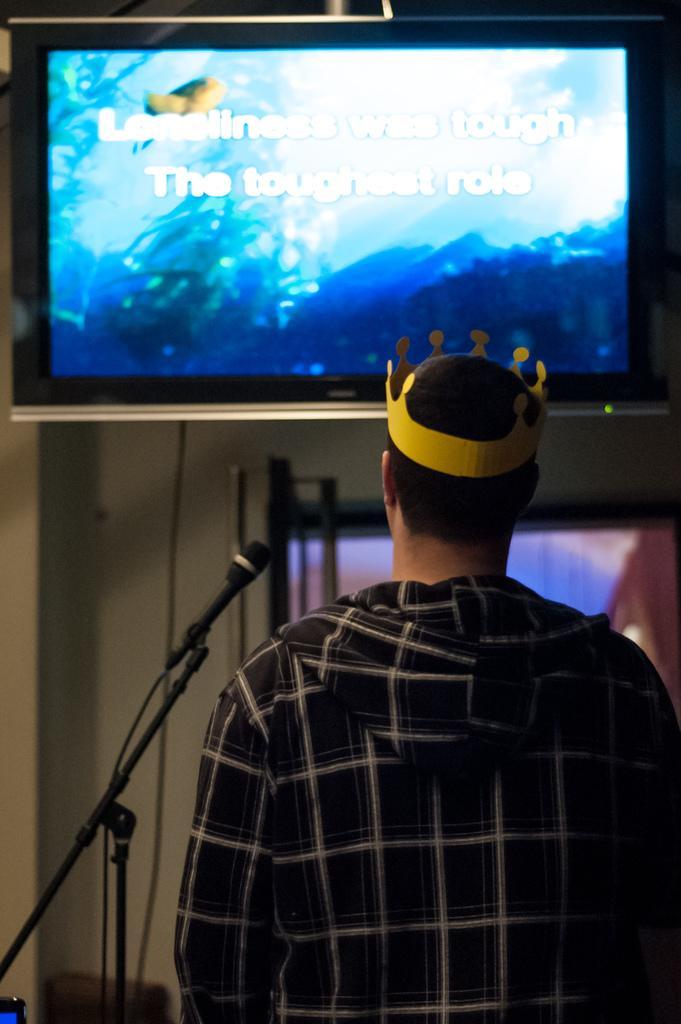How would you summarize this image in a sentence or two? In this image I can see the person standing and the person is wearing black color shirt. In the background I can see the microphone and the screen. 